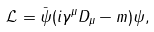Convert formula to latex. <formula><loc_0><loc_0><loc_500><loc_500>\mathcal { L } = \bar { \psi } ( i \gamma ^ { \mu } D _ { \mu } - m ) \psi ,</formula> 